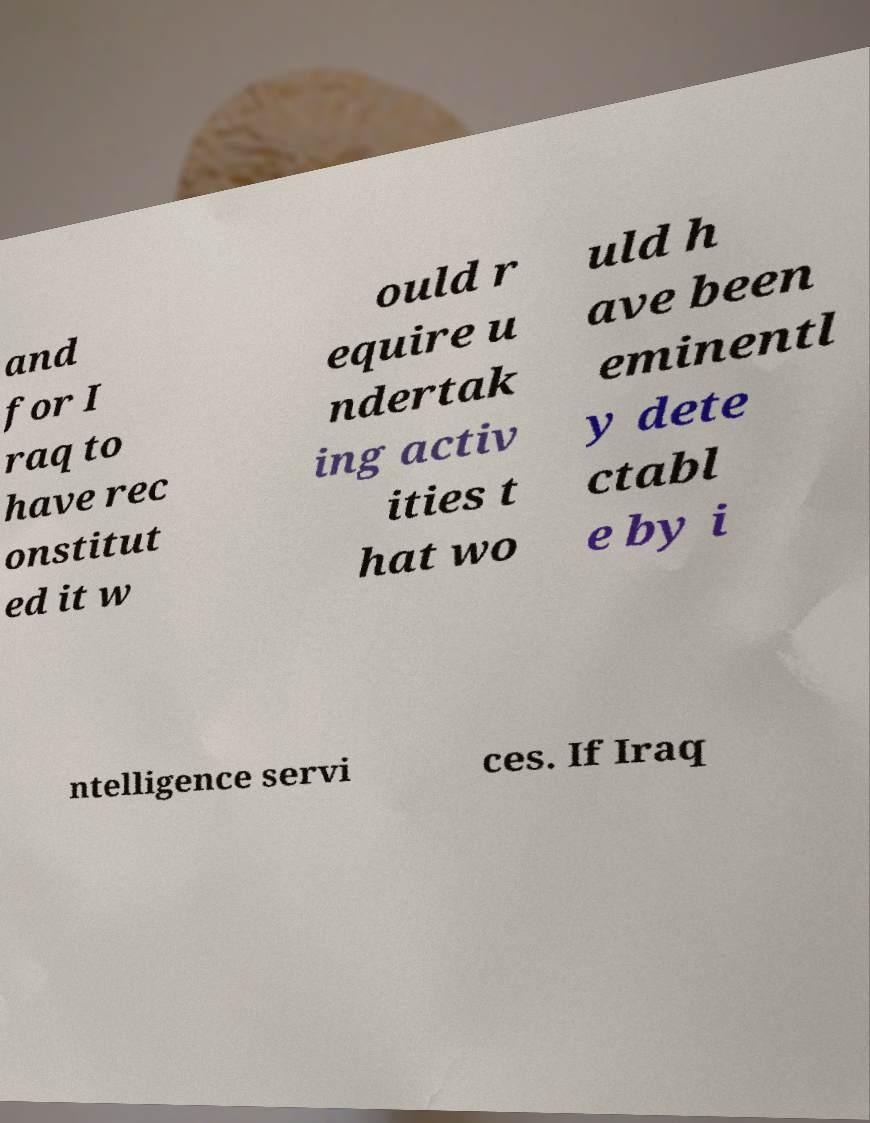Can you read and provide the text displayed in the image?This photo seems to have some interesting text. Can you extract and type it out for me? and for I raq to have rec onstitut ed it w ould r equire u ndertak ing activ ities t hat wo uld h ave been eminentl y dete ctabl e by i ntelligence servi ces. If Iraq 